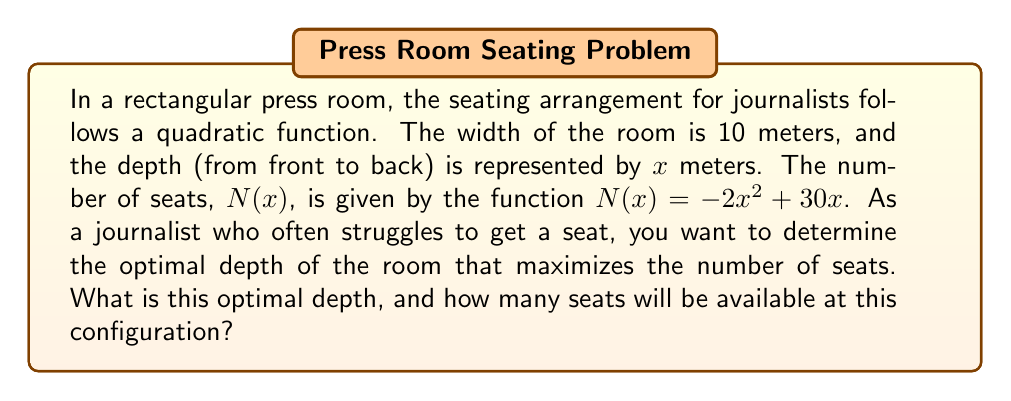Solve this math problem. To solve this problem, we need to follow these steps:

1) The number of seats is given by the quadratic function:
   $N(x) = -2x^2 + 30x$

2) To find the maximum number of seats, we need to find the vertex of this parabola. The vertex represents the highest point of the parabola, which in this case is the maximum number of seats.

3) For a quadratic function in the form $f(x) = ax^2 + bx + c$, the x-coordinate of the vertex is given by $x = -\frac{b}{2a}$.

4) In our case, $a = -2$ and $b = 30$. So:

   $x = -\frac{30}{2(-2)} = -\frac{30}{-4} = \frac{30}{4} = 7.5$

5) Therefore, the optimal depth of the room is 7.5 meters.

6) To find the number of seats at this optimal depth, we substitute $x = 7.5$ into our original function:

   $N(7.5) = -2(7.5)^2 + 30(7.5)$
           $= -2(56.25) + 225$
           $= -112.5 + 225$
           $= 112.5$

7) Since we can't have a fractional number of seats, we round down to the nearest whole number.
Answer: The optimal depth of the room is 7.5 meters, and at this depth, there will be 112 seats available. 